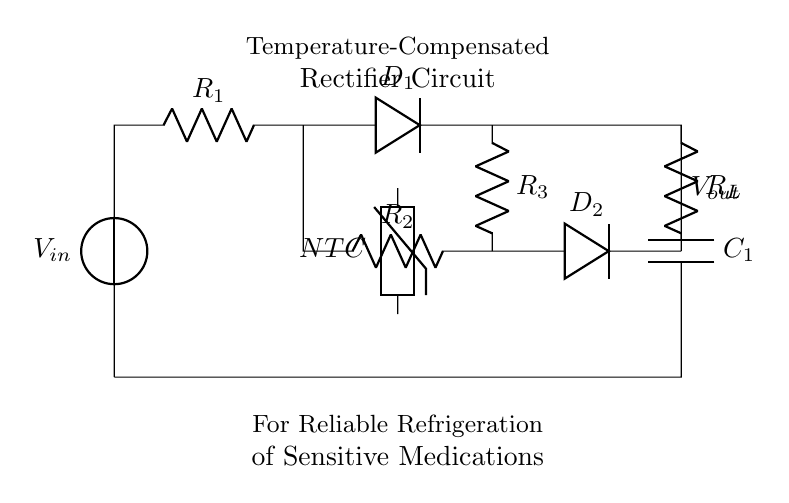What is the primary purpose of this rectifier circuit? The primary purpose is to provide a stable DC output voltage for refrigeration systems, ensuring sensitive medications are stored at the correct temperatures.
Answer: Reliable refrigeration of sensitive medications What type of diode is used in the circuit? The circuit uses two diodes, labeled D1 and D2, which are standard rectifier diodes to allow current to flow in one direction.
Answer: Rectifier diode Which component is used for temperature compensation? The component used for temperature compensation is the thermistor labeled NTC, which changes resistance with temperature variations, adjusting the output accordingly.
Answer: NTC thermistor How many resistors are present in this circuit? There are three resistors in this circuit, labeled R1, R2, and R3, each serving distinct functions for current regulation and component interaction.
Answer: Three resistors What is the output voltage node labeled as? The output voltage node is labeled as Vout, indicating the point where the corrected and smoothed DC voltage is available for refrigeration units.
Answer: Vout How does the NTC thermistor affect the circuit's performance? The NTC thermistor decreases resistance with increasing temperature, helping to maintain consistent output voltage despite temperature fluctuations in the refrigeration environment.
Answer: Stabilizes output voltage 